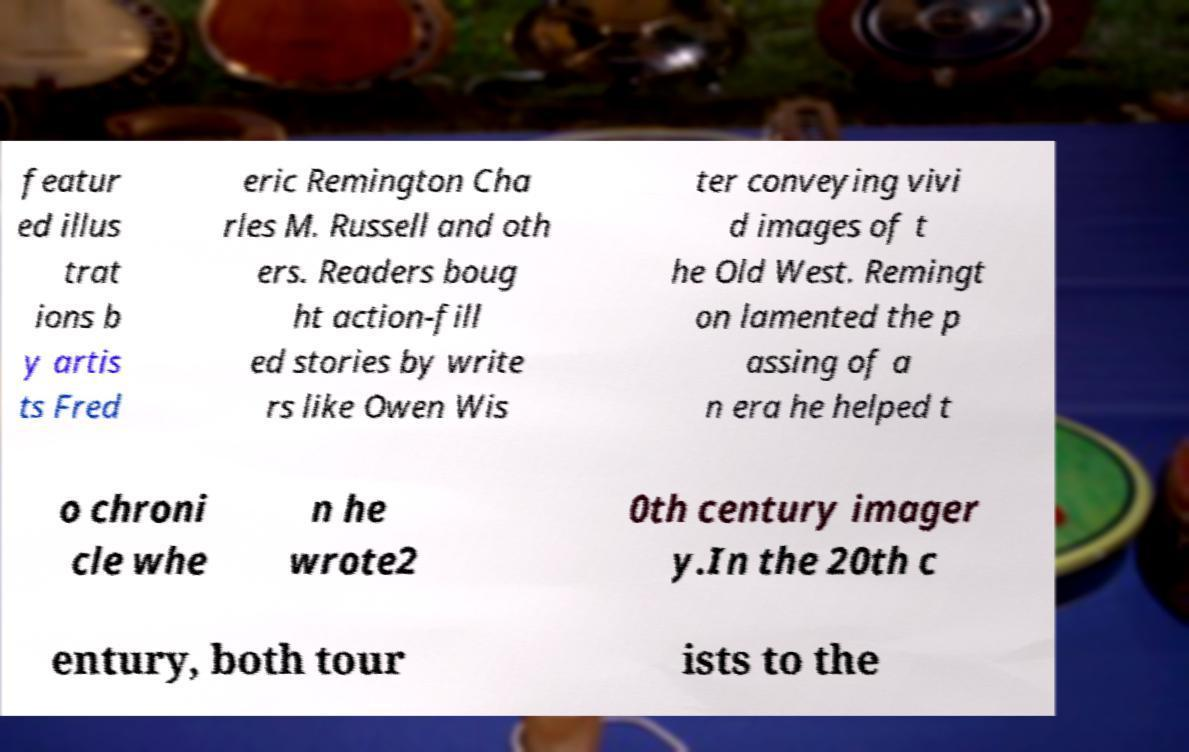Please identify and transcribe the text found in this image. featur ed illus trat ions b y artis ts Fred eric Remington Cha rles M. Russell and oth ers. Readers boug ht action-fill ed stories by write rs like Owen Wis ter conveying vivi d images of t he Old West. Remingt on lamented the p assing of a n era he helped t o chroni cle whe n he wrote2 0th century imager y.In the 20th c entury, both tour ists to the 